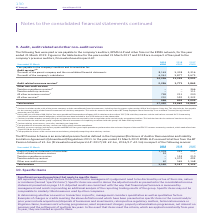According to Bt Group Plc's financial document, What fees were payable to PricewaterhouseCoopers LLP in relation to the audit of 2017/18 subsidiary accounts? According to the financial document, £446,000. The relevant text states: "amounting to £32,000. b During the year a further £446,000 of fees were payable to PricewaterhouseCoopers LLP in relation to the audit of 2017/18 subsidiary ac..." Also, What was The audit of the parent company and the consolidated financial statements in 2019? According to the financial document, 8,165 (in thousands). The relevant text states: "company and the consolidated financial statements 8,165 5,418 4,316 The audit of the company’s subsidiaries 6,061 5,877 5,675..." Also, What was the  All other services in 2019? According to the financial document, 210 (in thousands). The relevant text states: "rance services f 748 211 200 All other services g 210 592 2,332..." Also, can you calculate: What was the change in the The audit of the parent company and the consolidated financial statements from 2018 to 2019? Based on the calculation: 8,165 - 5,418, the result is 2747 (in thousands). This is based on the information: "company and the consolidated financial statements 8,165 5,418 4,316 The audit of the company’s subsidiaries 6,061 5,877 5,675 y and the consolidated financial statements 8,165 5,418 4,316 The audit of..." The key data points involved are: 5,418, 8,165. Also, can you calculate: What is the average The audit of the company’s subsidiaries from 2017-2019? To answer this question, I need to perform calculations using the financial data. The calculation is: (6,061 + 5,877 + 5,675) / 3, which equals 5871 (in thousands). This is based on the information: "316 The audit of the company’s subsidiaries 6,061 5,877 5,675 418 4,316 The audit of the company’s subsidiaries 6,061 5,877 5,675 e audit of the company’s subsidiaries 6,061 5,877 5,675..." The key data points involved are: 5,675, 5,877, 6,061. Also, can you calculate: What is the percentage change in the Total services from 2018 to 2019? To answer this question, I need to perform calculations using the financial data. The calculation is: 17,420 / 13,869 - 1, which equals 25.6 (percentage). This is based on the information: "Total services 17,420 13,869 14,865 Total services 17,420 13,869 14,865..." The key data points involved are: 13,869, 17,420. 